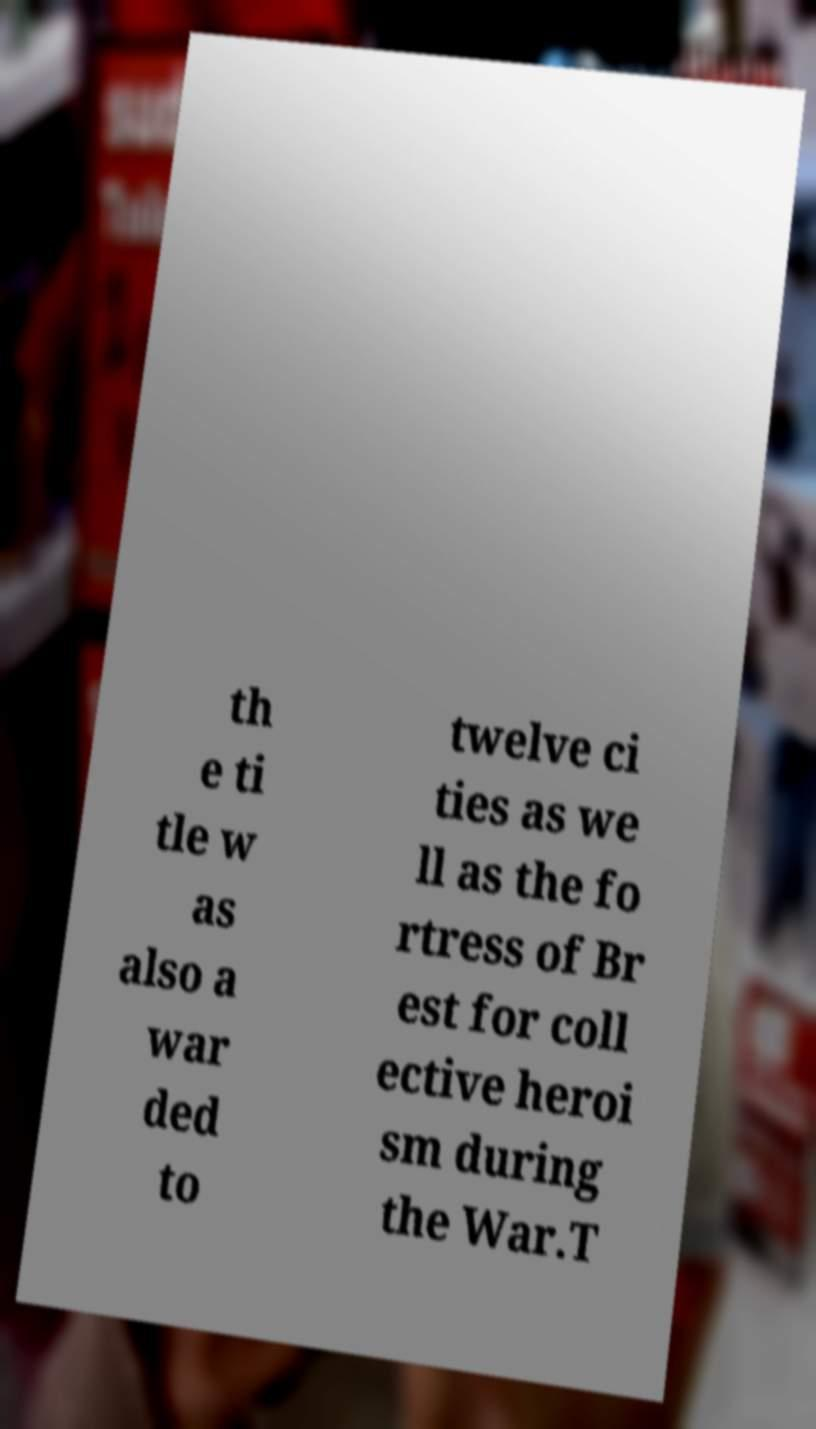I need the written content from this picture converted into text. Can you do that? th e ti tle w as also a war ded to twelve ci ties as we ll as the fo rtress of Br est for coll ective heroi sm during the War.T 